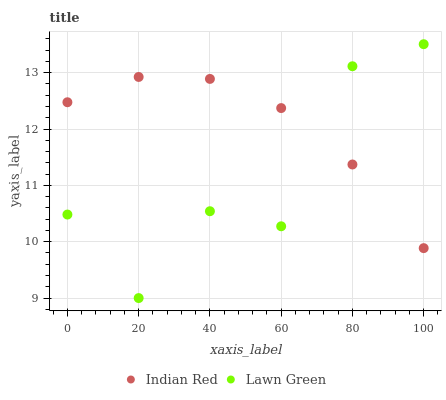Does Lawn Green have the minimum area under the curve?
Answer yes or no. Yes. Does Indian Red have the maximum area under the curve?
Answer yes or no. Yes. Does Indian Red have the minimum area under the curve?
Answer yes or no. No. Is Indian Red the smoothest?
Answer yes or no. Yes. Is Lawn Green the roughest?
Answer yes or no. Yes. Is Indian Red the roughest?
Answer yes or no. No. Does Lawn Green have the lowest value?
Answer yes or no. Yes. Does Indian Red have the lowest value?
Answer yes or no. No. Does Lawn Green have the highest value?
Answer yes or no. Yes. Does Indian Red have the highest value?
Answer yes or no. No. Does Indian Red intersect Lawn Green?
Answer yes or no. Yes. Is Indian Red less than Lawn Green?
Answer yes or no. No. Is Indian Red greater than Lawn Green?
Answer yes or no. No. 